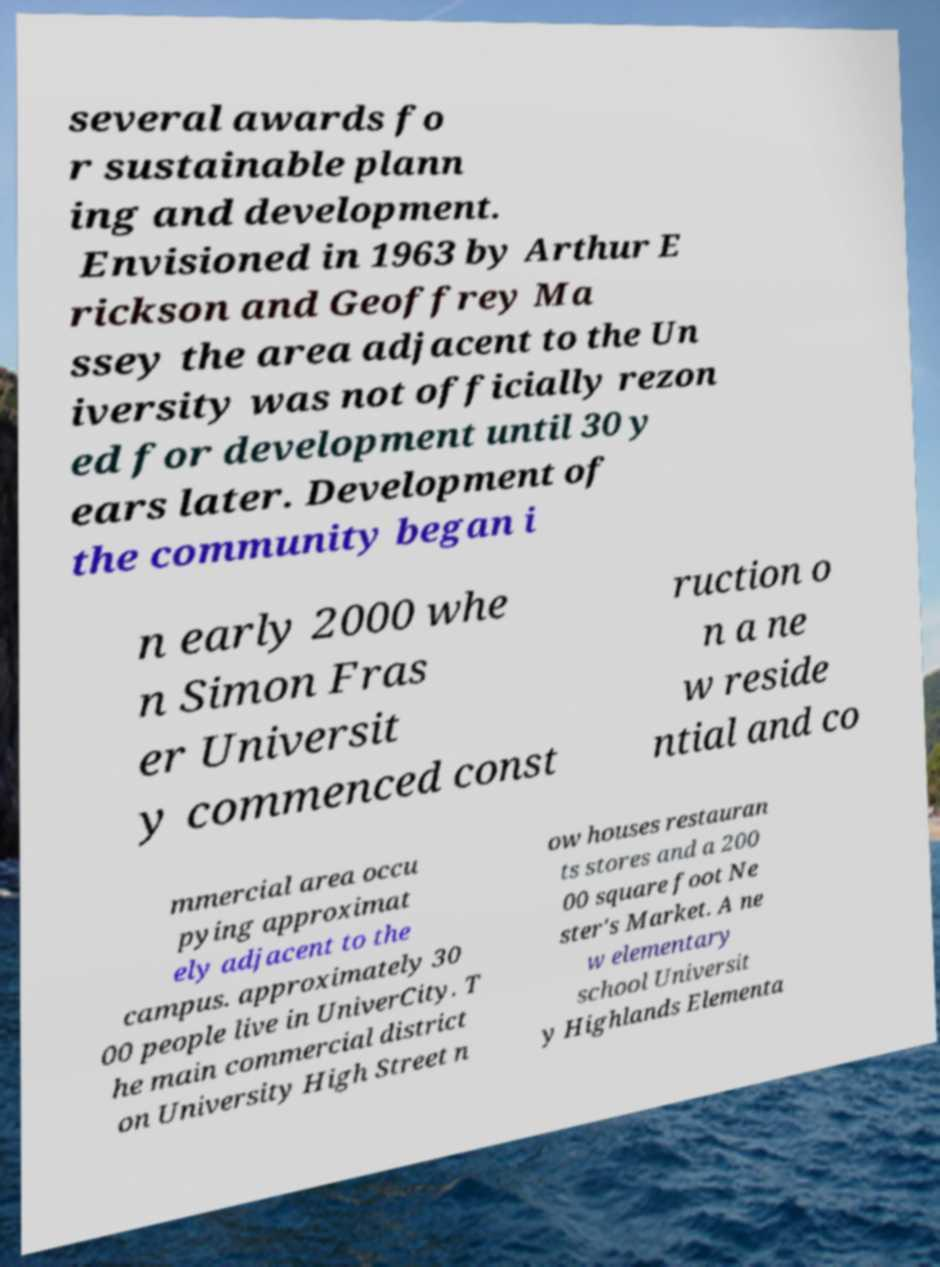Could you assist in decoding the text presented in this image and type it out clearly? several awards fo r sustainable plann ing and development. Envisioned in 1963 by Arthur E rickson and Geoffrey Ma ssey the area adjacent to the Un iversity was not officially rezon ed for development until 30 y ears later. Development of the community began i n early 2000 whe n Simon Fras er Universit y commenced const ruction o n a ne w reside ntial and co mmercial area occu pying approximat ely adjacent to the campus. approximately 30 00 people live in UniverCity. T he main commercial district on University High Street n ow houses restauran ts stores and a 200 00 square foot Ne ster's Market. A ne w elementary school Universit y Highlands Elementa 